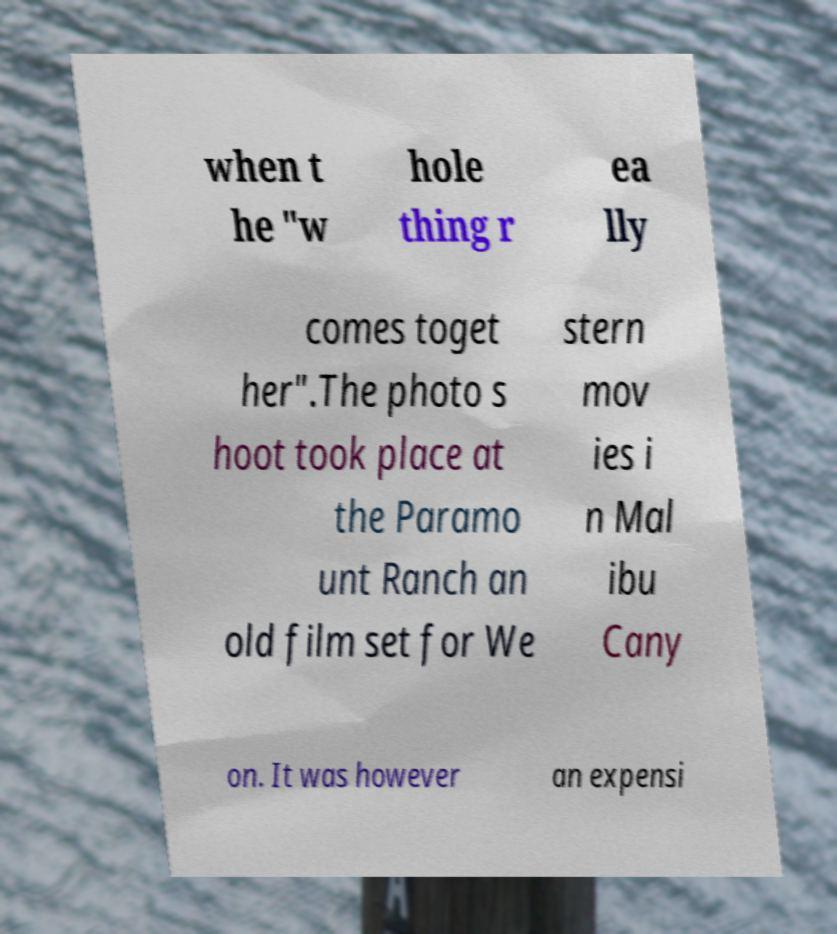What messages or text are displayed in this image? I need them in a readable, typed format. when t he "w hole thing r ea lly comes toget her".The photo s hoot took place at the Paramo unt Ranch an old film set for We stern mov ies i n Mal ibu Cany on. It was however an expensi 